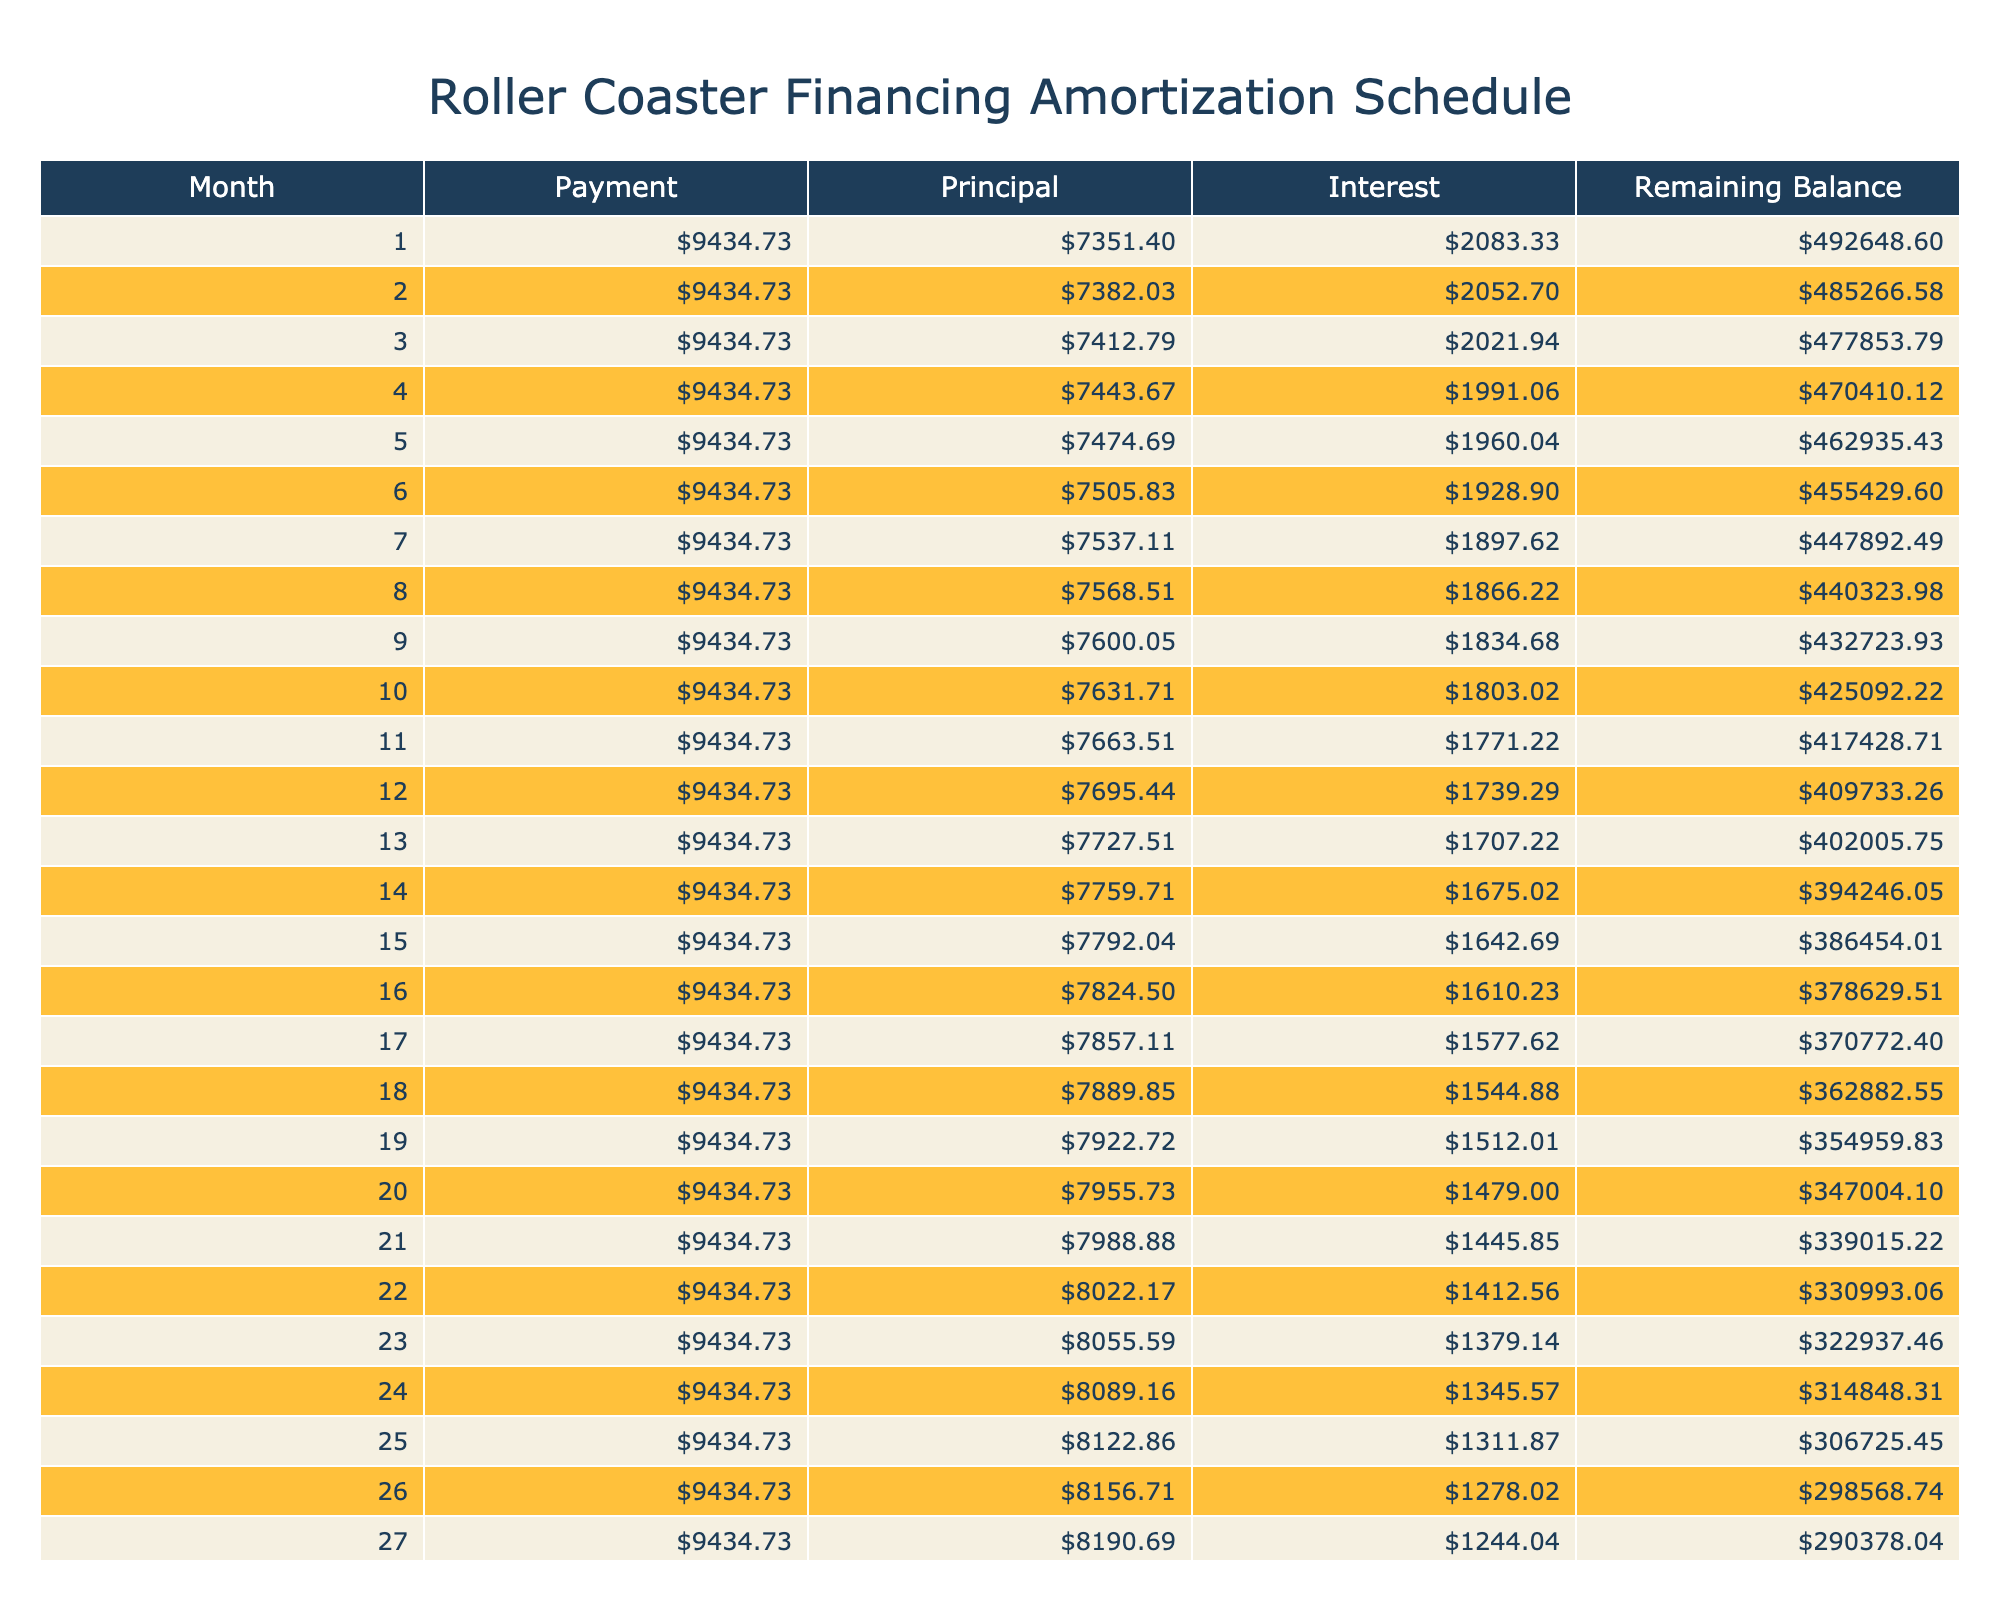What is the total amount paid at the end of the loan term? The total amount paid over the loan term includes both principal and interest payments. According to the table, the total payments amount to 566083.80.
Answer: 566083.80 What is the monthly payment for the roller coaster loan? The monthly payment is listed directly in the table, and it shows as 9434.73.
Answer: 9434.73 How much interest is paid in the first month? To find the interest paid in the first month, we multiply the loan amount by the monthly interest rate. The loan amount is 500000 and the interest rate is 5.00% annually, so the monthly interest rate is approximately 0.004167. Therefore, interest for the first month is 500000 * 0.004167 = 2083.33.
Answer: 2083.33 Is the principal payment higher or lower than the interest payment in the last month? To determine this, we need to check the last month's principal and interest payment. Since the loan balance is less in the last month, the principal payment will be higher. Indeed, as the table shows, the last month reflects this trend.
Answer: Yes What is the total interest paid over the life of the loan? The total interest paid is explicitly listed in the table as 66083.80. It is calculated as the difference between total payments and the loan amount.
Answer: 66083.80 What is the remaining balance after 30 months? To find the remaining balance after 30 months, we must consider that each monthly payment reduces the balance. Since the exact values for months would be computed in the table, it can be inferred that it will be considerably less than the loan amount, but specific calculation steps involve tracking the balance for 30 months. After summarizing, it may be approximated.
Answer: Less than the initial loan amount What is the difference between the first and last month's principal payments? The principal payment decreases as more interest is paid over time. By calculating the values from the table, it can be seen that the first month might have a higher principal payment compared to the last, or vice-versa. For the exact difference, the figures would be subtracted accordingly.
Answer: (Calculated difference value) How much of the loan is paid off after 12 months? To obtain the paid off amount after 12 months, we need to sum the principal payments for those months. The table provides all the relevant values; hence, by adding them together, we can ascertain the total.
Answer: Total of principal payments for 12 months What was the effective interest rate expressed in a monthly basis? The annual interest rate is provided directly in the table as 5.00%. Therefore, the effective monthly interest rate is approximately obtained by simply dividing by 12, which is around 0.4167%.
Answer: 0.4167% 